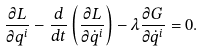<formula> <loc_0><loc_0><loc_500><loc_500>\frac { \partial L } { \partial q ^ { i } } - \frac { d } { d t } \left ( \frac { \partial L } { \partial { \dot { q } } ^ { i } } \right ) - \lambda \frac { \partial G } { \partial { \dot { q } } ^ { i } } = 0 .</formula> 